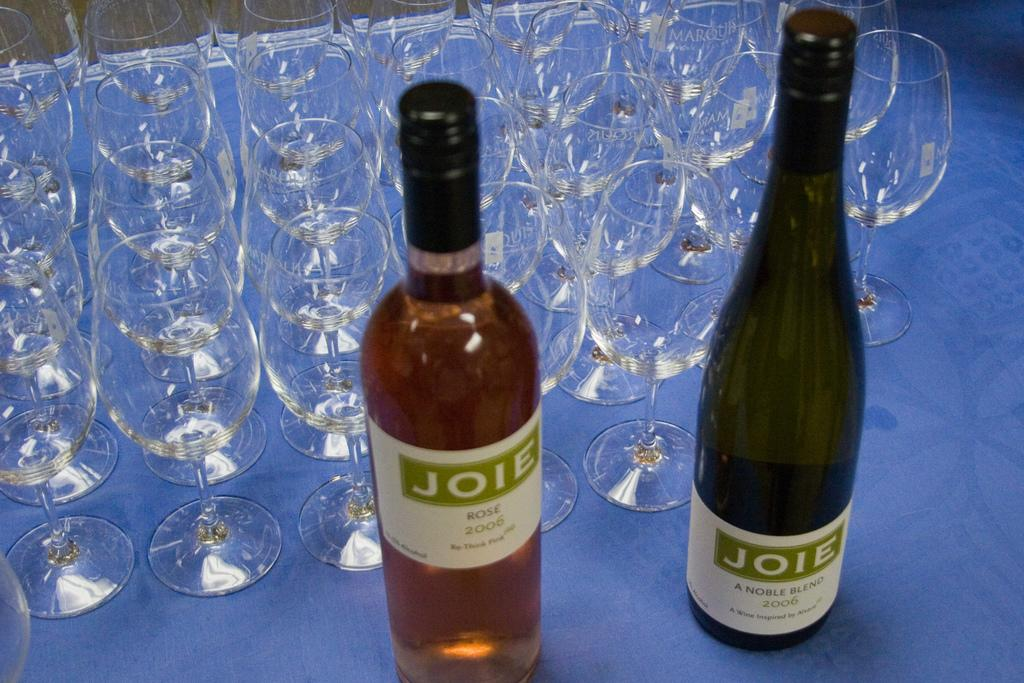<image>
Provide a brief description of the given image. A rose and a white bottle of Joie wine sit unopened on a table next to dozens of empty and sprkling clean wine glasses. 